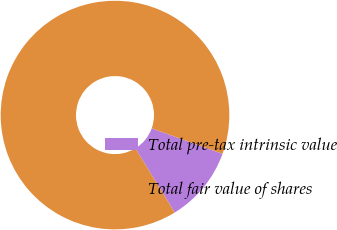Convert chart. <chart><loc_0><loc_0><loc_500><loc_500><pie_chart><fcel>Total pre-tax intrinsic value<fcel>Total fair value of shares<nl><fcel>10.75%<fcel>89.25%<nl></chart> 